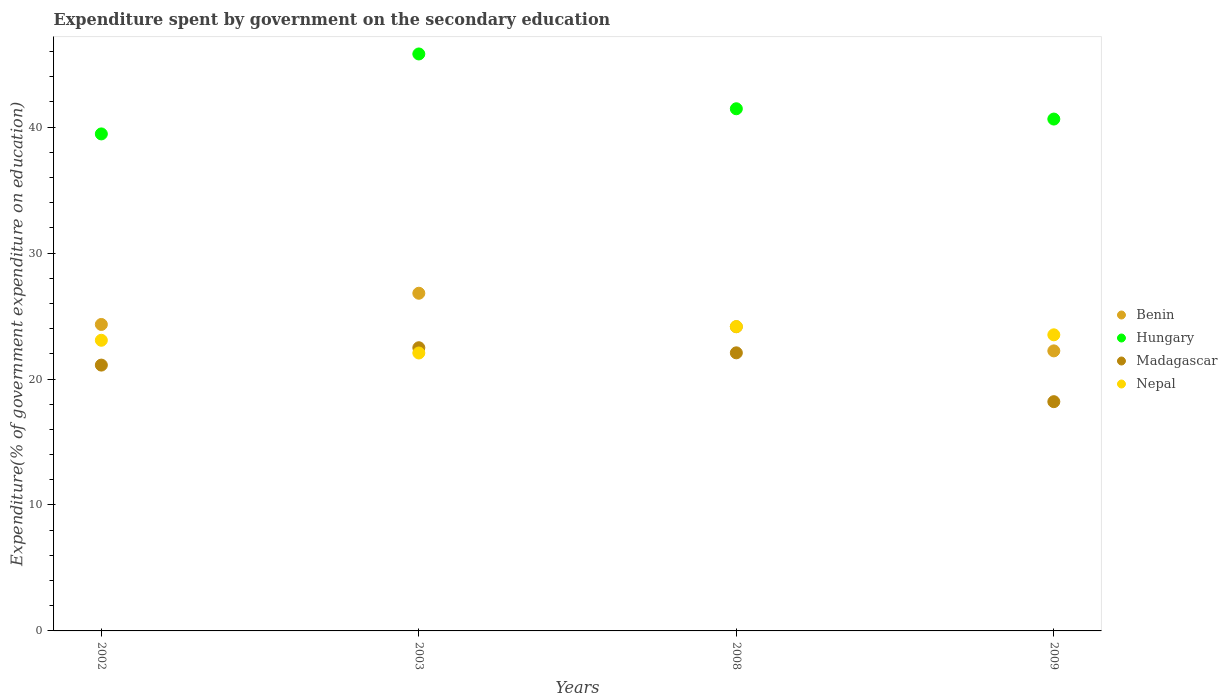How many different coloured dotlines are there?
Give a very brief answer. 4. What is the expenditure spent by government on the secondary education in Benin in 2009?
Provide a succinct answer. 22.23. Across all years, what is the maximum expenditure spent by government on the secondary education in Nepal?
Provide a succinct answer. 24.16. Across all years, what is the minimum expenditure spent by government on the secondary education in Benin?
Give a very brief answer. 22.23. In which year was the expenditure spent by government on the secondary education in Hungary minimum?
Ensure brevity in your answer.  2002. What is the total expenditure spent by government on the secondary education in Benin in the graph?
Offer a very short reply. 97.53. What is the difference between the expenditure spent by government on the secondary education in Hungary in 2002 and that in 2009?
Your answer should be compact. -1.18. What is the difference between the expenditure spent by government on the secondary education in Hungary in 2009 and the expenditure spent by government on the secondary education in Madagascar in 2008?
Your answer should be compact. 18.56. What is the average expenditure spent by government on the secondary education in Hungary per year?
Give a very brief answer. 41.84. In the year 2002, what is the difference between the expenditure spent by government on the secondary education in Nepal and expenditure spent by government on the secondary education in Madagascar?
Your answer should be very brief. 1.97. In how many years, is the expenditure spent by government on the secondary education in Madagascar greater than 4 %?
Offer a very short reply. 4. What is the ratio of the expenditure spent by government on the secondary education in Nepal in 2003 to that in 2009?
Your answer should be very brief. 0.94. What is the difference between the highest and the second highest expenditure spent by government on the secondary education in Benin?
Provide a short and direct response. 2.48. What is the difference between the highest and the lowest expenditure spent by government on the secondary education in Benin?
Keep it short and to the point. 4.58. Is the sum of the expenditure spent by government on the secondary education in Benin in 2002 and 2003 greater than the maximum expenditure spent by government on the secondary education in Madagascar across all years?
Provide a short and direct response. Yes. What is the difference between two consecutive major ticks on the Y-axis?
Ensure brevity in your answer.  10. How many legend labels are there?
Your response must be concise. 4. What is the title of the graph?
Keep it short and to the point. Expenditure spent by government on the secondary education. Does "Barbados" appear as one of the legend labels in the graph?
Your answer should be compact. No. What is the label or title of the X-axis?
Ensure brevity in your answer.  Years. What is the label or title of the Y-axis?
Ensure brevity in your answer.  Expenditure(% of government expenditure on education). What is the Expenditure(% of government expenditure on education) in Benin in 2002?
Make the answer very short. 24.33. What is the Expenditure(% of government expenditure on education) of Hungary in 2002?
Your answer should be very brief. 39.46. What is the Expenditure(% of government expenditure on education) of Madagascar in 2002?
Your answer should be compact. 21.11. What is the Expenditure(% of government expenditure on education) of Nepal in 2002?
Give a very brief answer. 23.08. What is the Expenditure(% of government expenditure on education) of Benin in 2003?
Provide a short and direct response. 26.81. What is the Expenditure(% of government expenditure on education) of Hungary in 2003?
Your answer should be compact. 45.81. What is the Expenditure(% of government expenditure on education) of Madagascar in 2003?
Provide a short and direct response. 22.48. What is the Expenditure(% of government expenditure on education) in Nepal in 2003?
Give a very brief answer. 22.07. What is the Expenditure(% of government expenditure on education) of Benin in 2008?
Ensure brevity in your answer.  24.15. What is the Expenditure(% of government expenditure on education) in Hungary in 2008?
Your response must be concise. 41.46. What is the Expenditure(% of government expenditure on education) in Madagascar in 2008?
Offer a terse response. 22.08. What is the Expenditure(% of government expenditure on education) of Nepal in 2008?
Your response must be concise. 24.16. What is the Expenditure(% of government expenditure on education) of Benin in 2009?
Give a very brief answer. 22.23. What is the Expenditure(% of government expenditure on education) of Hungary in 2009?
Your answer should be very brief. 40.64. What is the Expenditure(% of government expenditure on education) of Madagascar in 2009?
Offer a terse response. 18.2. What is the Expenditure(% of government expenditure on education) of Nepal in 2009?
Your answer should be very brief. 23.51. Across all years, what is the maximum Expenditure(% of government expenditure on education) in Benin?
Offer a terse response. 26.81. Across all years, what is the maximum Expenditure(% of government expenditure on education) of Hungary?
Your answer should be very brief. 45.81. Across all years, what is the maximum Expenditure(% of government expenditure on education) in Madagascar?
Your response must be concise. 22.48. Across all years, what is the maximum Expenditure(% of government expenditure on education) of Nepal?
Your answer should be very brief. 24.16. Across all years, what is the minimum Expenditure(% of government expenditure on education) of Benin?
Your response must be concise. 22.23. Across all years, what is the minimum Expenditure(% of government expenditure on education) in Hungary?
Provide a short and direct response. 39.46. Across all years, what is the minimum Expenditure(% of government expenditure on education) in Madagascar?
Give a very brief answer. 18.2. Across all years, what is the minimum Expenditure(% of government expenditure on education) in Nepal?
Your response must be concise. 22.07. What is the total Expenditure(% of government expenditure on education) in Benin in the graph?
Your answer should be compact. 97.53. What is the total Expenditure(% of government expenditure on education) of Hungary in the graph?
Your answer should be compact. 167.37. What is the total Expenditure(% of government expenditure on education) in Madagascar in the graph?
Provide a short and direct response. 83.87. What is the total Expenditure(% of government expenditure on education) in Nepal in the graph?
Your response must be concise. 92.82. What is the difference between the Expenditure(% of government expenditure on education) of Benin in 2002 and that in 2003?
Provide a succinct answer. -2.48. What is the difference between the Expenditure(% of government expenditure on education) of Hungary in 2002 and that in 2003?
Your answer should be very brief. -6.35. What is the difference between the Expenditure(% of government expenditure on education) of Madagascar in 2002 and that in 2003?
Offer a very short reply. -1.38. What is the difference between the Expenditure(% of government expenditure on education) of Nepal in 2002 and that in 2003?
Your response must be concise. 1.01. What is the difference between the Expenditure(% of government expenditure on education) of Benin in 2002 and that in 2008?
Provide a short and direct response. 0.18. What is the difference between the Expenditure(% of government expenditure on education) in Hungary in 2002 and that in 2008?
Offer a terse response. -2. What is the difference between the Expenditure(% of government expenditure on education) of Madagascar in 2002 and that in 2008?
Your answer should be very brief. -0.97. What is the difference between the Expenditure(% of government expenditure on education) of Nepal in 2002 and that in 2008?
Your response must be concise. -1.09. What is the difference between the Expenditure(% of government expenditure on education) of Benin in 2002 and that in 2009?
Ensure brevity in your answer.  2.1. What is the difference between the Expenditure(% of government expenditure on education) in Hungary in 2002 and that in 2009?
Make the answer very short. -1.18. What is the difference between the Expenditure(% of government expenditure on education) of Madagascar in 2002 and that in 2009?
Keep it short and to the point. 2.9. What is the difference between the Expenditure(% of government expenditure on education) of Nepal in 2002 and that in 2009?
Offer a very short reply. -0.43. What is the difference between the Expenditure(% of government expenditure on education) in Benin in 2003 and that in 2008?
Offer a very short reply. 2.66. What is the difference between the Expenditure(% of government expenditure on education) in Hungary in 2003 and that in 2008?
Your response must be concise. 4.35. What is the difference between the Expenditure(% of government expenditure on education) of Madagascar in 2003 and that in 2008?
Offer a terse response. 0.4. What is the difference between the Expenditure(% of government expenditure on education) of Nepal in 2003 and that in 2008?
Give a very brief answer. -2.1. What is the difference between the Expenditure(% of government expenditure on education) of Benin in 2003 and that in 2009?
Offer a terse response. 4.58. What is the difference between the Expenditure(% of government expenditure on education) in Hungary in 2003 and that in 2009?
Your answer should be compact. 5.17. What is the difference between the Expenditure(% of government expenditure on education) of Madagascar in 2003 and that in 2009?
Your answer should be compact. 4.28. What is the difference between the Expenditure(% of government expenditure on education) of Nepal in 2003 and that in 2009?
Offer a terse response. -1.44. What is the difference between the Expenditure(% of government expenditure on education) of Benin in 2008 and that in 2009?
Keep it short and to the point. 1.92. What is the difference between the Expenditure(% of government expenditure on education) in Hungary in 2008 and that in 2009?
Offer a very short reply. 0.82. What is the difference between the Expenditure(% of government expenditure on education) in Madagascar in 2008 and that in 2009?
Make the answer very short. 3.88. What is the difference between the Expenditure(% of government expenditure on education) in Nepal in 2008 and that in 2009?
Your answer should be very brief. 0.65. What is the difference between the Expenditure(% of government expenditure on education) in Benin in 2002 and the Expenditure(% of government expenditure on education) in Hungary in 2003?
Provide a succinct answer. -21.48. What is the difference between the Expenditure(% of government expenditure on education) of Benin in 2002 and the Expenditure(% of government expenditure on education) of Madagascar in 2003?
Your response must be concise. 1.85. What is the difference between the Expenditure(% of government expenditure on education) in Benin in 2002 and the Expenditure(% of government expenditure on education) in Nepal in 2003?
Offer a terse response. 2.27. What is the difference between the Expenditure(% of government expenditure on education) in Hungary in 2002 and the Expenditure(% of government expenditure on education) in Madagascar in 2003?
Keep it short and to the point. 16.98. What is the difference between the Expenditure(% of government expenditure on education) of Hungary in 2002 and the Expenditure(% of government expenditure on education) of Nepal in 2003?
Your answer should be very brief. 17.39. What is the difference between the Expenditure(% of government expenditure on education) in Madagascar in 2002 and the Expenditure(% of government expenditure on education) in Nepal in 2003?
Provide a short and direct response. -0.96. What is the difference between the Expenditure(% of government expenditure on education) of Benin in 2002 and the Expenditure(% of government expenditure on education) of Hungary in 2008?
Provide a succinct answer. -17.13. What is the difference between the Expenditure(% of government expenditure on education) in Benin in 2002 and the Expenditure(% of government expenditure on education) in Madagascar in 2008?
Provide a succinct answer. 2.25. What is the difference between the Expenditure(% of government expenditure on education) of Benin in 2002 and the Expenditure(% of government expenditure on education) of Nepal in 2008?
Your answer should be compact. 0.17. What is the difference between the Expenditure(% of government expenditure on education) of Hungary in 2002 and the Expenditure(% of government expenditure on education) of Madagascar in 2008?
Your response must be concise. 17.38. What is the difference between the Expenditure(% of government expenditure on education) in Hungary in 2002 and the Expenditure(% of government expenditure on education) in Nepal in 2008?
Offer a very short reply. 15.3. What is the difference between the Expenditure(% of government expenditure on education) in Madagascar in 2002 and the Expenditure(% of government expenditure on education) in Nepal in 2008?
Give a very brief answer. -3.06. What is the difference between the Expenditure(% of government expenditure on education) in Benin in 2002 and the Expenditure(% of government expenditure on education) in Hungary in 2009?
Give a very brief answer. -16.31. What is the difference between the Expenditure(% of government expenditure on education) of Benin in 2002 and the Expenditure(% of government expenditure on education) of Madagascar in 2009?
Your answer should be very brief. 6.13. What is the difference between the Expenditure(% of government expenditure on education) in Benin in 2002 and the Expenditure(% of government expenditure on education) in Nepal in 2009?
Offer a very short reply. 0.82. What is the difference between the Expenditure(% of government expenditure on education) of Hungary in 2002 and the Expenditure(% of government expenditure on education) of Madagascar in 2009?
Keep it short and to the point. 21.26. What is the difference between the Expenditure(% of government expenditure on education) of Hungary in 2002 and the Expenditure(% of government expenditure on education) of Nepal in 2009?
Provide a succinct answer. 15.95. What is the difference between the Expenditure(% of government expenditure on education) of Madagascar in 2002 and the Expenditure(% of government expenditure on education) of Nepal in 2009?
Keep it short and to the point. -2.4. What is the difference between the Expenditure(% of government expenditure on education) in Benin in 2003 and the Expenditure(% of government expenditure on education) in Hungary in 2008?
Offer a very short reply. -14.65. What is the difference between the Expenditure(% of government expenditure on education) of Benin in 2003 and the Expenditure(% of government expenditure on education) of Madagascar in 2008?
Keep it short and to the point. 4.73. What is the difference between the Expenditure(% of government expenditure on education) of Benin in 2003 and the Expenditure(% of government expenditure on education) of Nepal in 2008?
Your answer should be compact. 2.65. What is the difference between the Expenditure(% of government expenditure on education) of Hungary in 2003 and the Expenditure(% of government expenditure on education) of Madagascar in 2008?
Keep it short and to the point. 23.73. What is the difference between the Expenditure(% of government expenditure on education) in Hungary in 2003 and the Expenditure(% of government expenditure on education) in Nepal in 2008?
Offer a terse response. 21.65. What is the difference between the Expenditure(% of government expenditure on education) in Madagascar in 2003 and the Expenditure(% of government expenditure on education) in Nepal in 2008?
Your answer should be compact. -1.68. What is the difference between the Expenditure(% of government expenditure on education) of Benin in 2003 and the Expenditure(% of government expenditure on education) of Hungary in 2009?
Your response must be concise. -13.83. What is the difference between the Expenditure(% of government expenditure on education) in Benin in 2003 and the Expenditure(% of government expenditure on education) in Madagascar in 2009?
Your answer should be very brief. 8.61. What is the difference between the Expenditure(% of government expenditure on education) in Benin in 2003 and the Expenditure(% of government expenditure on education) in Nepal in 2009?
Make the answer very short. 3.3. What is the difference between the Expenditure(% of government expenditure on education) of Hungary in 2003 and the Expenditure(% of government expenditure on education) of Madagascar in 2009?
Your answer should be very brief. 27.61. What is the difference between the Expenditure(% of government expenditure on education) of Hungary in 2003 and the Expenditure(% of government expenditure on education) of Nepal in 2009?
Provide a short and direct response. 22.3. What is the difference between the Expenditure(% of government expenditure on education) of Madagascar in 2003 and the Expenditure(% of government expenditure on education) of Nepal in 2009?
Make the answer very short. -1.03. What is the difference between the Expenditure(% of government expenditure on education) of Benin in 2008 and the Expenditure(% of government expenditure on education) of Hungary in 2009?
Keep it short and to the point. -16.49. What is the difference between the Expenditure(% of government expenditure on education) in Benin in 2008 and the Expenditure(% of government expenditure on education) in Madagascar in 2009?
Keep it short and to the point. 5.95. What is the difference between the Expenditure(% of government expenditure on education) of Benin in 2008 and the Expenditure(% of government expenditure on education) of Nepal in 2009?
Offer a very short reply. 0.64. What is the difference between the Expenditure(% of government expenditure on education) of Hungary in 2008 and the Expenditure(% of government expenditure on education) of Madagascar in 2009?
Your answer should be compact. 23.26. What is the difference between the Expenditure(% of government expenditure on education) in Hungary in 2008 and the Expenditure(% of government expenditure on education) in Nepal in 2009?
Keep it short and to the point. 17.95. What is the difference between the Expenditure(% of government expenditure on education) in Madagascar in 2008 and the Expenditure(% of government expenditure on education) in Nepal in 2009?
Provide a short and direct response. -1.43. What is the average Expenditure(% of government expenditure on education) in Benin per year?
Your answer should be very brief. 24.38. What is the average Expenditure(% of government expenditure on education) of Hungary per year?
Your answer should be very brief. 41.84. What is the average Expenditure(% of government expenditure on education) in Madagascar per year?
Provide a succinct answer. 20.97. What is the average Expenditure(% of government expenditure on education) of Nepal per year?
Keep it short and to the point. 23.2. In the year 2002, what is the difference between the Expenditure(% of government expenditure on education) in Benin and Expenditure(% of government expenditure on education) in Hungary?
Your answer should be compact. -15.13. In the year 2002, what is the difference between the Expenditure(% of government expenditure on education) of Benin and Expenditure(% of government expenditure on education) of Madagascar?
Provide a succinct answer. 3.23. In the year 2002, what is the difference between the Expenditure(% of government expenditure on education) of Benin and Expenditure(% of government expenditure on education) of Nepal?
Ensure brevity in your answer.  1.26. In the year 2002, what is the difference between the Expenditure(% of government expenditure on education) of Hungary and Expenditure(% of government expenditure on education) of Madagascar?
Give a very brief answer. 18.35. In the year 2002, what is the difference between the Expenditure(% of government expenditure on education) of Hungary and Expenditure(% of government expenditure on education) of Nepal?
Keep it short and to the point. 16.38. In the year 2002, what is the difference between the Expenditure(% of government expenditure on education) in Madagascar and Expenditure(% of government expenditure on education) in Nepal?
Your response must be concise. -1.97. In the year 2003, what is the difference between the Expenditure(% of government expenditure on education) in Benin and Expenditure(% of government expenditure on education) in Hungary?
Offer a very short reply. -19. In the year 2003, what is the difference between the Expenditure(% of government expenditure on education) of Benin and Expenditure(% of government expenditure on education) of Madagascar?
Make the answer very short. 4.33. In the year 2003, what is the difference between the Expenditure(% of government expenditure on education) of Benin and Expenditure(% of government expenditure on education) of Nepal?
Your answer should be compact. 4.74. In the year 2003, what is the difference between the Expenditure(% of government expenditure on education) in Hungary and Expenditure(% of government expenditure on education) in Madagascar?
Provide a short and direct response. 23.32. In the year 2003, what is the difference between the Expenditure(% of government expenditure on education) of Hungary and Expenditure(% of government expenditure on education) of Nepal?
Ensure brevity in your answer.  23.74. In the year 2003, what is the difference between the Expenditure(% of government expenditure on education) in Madagascar and Expenditure(% of government expenditure on education) in Nepal?
Keep it short and to the point. 0.42. In the year 2008, what is the difference between the Expenditure(% of government expenditure on education) in Benin and Expenditure(% of government expenditure on education) in Hungary?
Provide a short and direct response. -17.31. In the year 2008, what is the difference between the Expenditure(% of government expenditure on education) in Benin and Expenditure(% of government expenditure on education) in Madagascar?
Ensure brevity in your answer.  2.07. In the year 2008, what is the difference between the Expenditure(% of government expenditure on education) in Benin and Expenditure(% of government expenditure on education) in Nepal?
Keep it short and to the point. -0.01. In the year 2008, what is the difference between the Expenditure(% of government expenditure on education) of Hungary and Expenditure(% of government expenditure on education) of Madagascar?
Provide a succinct answer. 19.38. In the year 2008, what is the difference between the Expenditure(% of government expenditure on education) in Hungary and Expenditure(% of government expenditure on education) in Nepal?
Your response must be concise. 17.29. In the year 2008, what is the difference between the Expenditure(% of government expenditure on education) of Madagascar and Expenditure(% of government expenditure on education) of Nepal?
Provide a succinct answer. -2.08. In the year 2009, what is the difference between the Expenditure(% of government expenditure on education) of Benin and Expenditure(% of government expenditure on education) of Hungary?
Give a very brief answer. -18.41. In the year 2009, what is the difference between the Expenditure(% of government expenditure on education) of Benin and Expenditure(% of government expenditure on education) of Madagascar?
Give a very brief answer. 4.03. In the year 2009, what is the difference between the Expenditure(% of government expenditure on education) of Benin and Expenditure(% of government expenditure on education) of Nepal?
Your response must be concise. -1.27. In the year 2009, what is the difference between the Expenditure(% of government expenditure on education) in Hungary and Expenditure(% of government expenditure on education) in Madagascar?
Keep it short and to the point. 22.44. In the year 2009, what is the difference between the Expenditure(% of government expenditure on education) of Hungary and Expenditure(% of government expenditure on education) of Nepal?
Keep it short and to the point. 17.13. In the year 2009, what is the difference between the Expenditure(% of government expenditure on education) in Madagascar and Expenditure(% of government expenditure on education) in Nepal?
Give a very brief answer. -5.31. What is the ratio of the Expenditure(% of government expenditure on education) in Benin in 2002 to that in 2003?
Provide a succinct answer. 0.91. What is the ratio of the Expenditure(% of government expenditure on education) in Hungary in 2002 to that in 2003?
Give a very brief answer. 0.86. What is the ratio of the Expenditure(% of government expenditure on education) of Madagascar in 2002 to that in 2003?
Offer a terse response. 0.94. What is the ratio of the Expenditure(% of government expenditure on education) of Nepal in 2002 to that in 2003?
Your answer should be very brief. 1.05. What is the ratio of the Expenditure(% of government expenditure on education) of Benin in 2002 to that in 2008?
Give a very brief answer. 1.01. What is the ratio of the Expenditure(% of government expenditure on education) in Hungary in 2002 to that in 2008?
Give a very brief answer. 0.95. What is the ratio of the Expenditure(% of government expenditure on education) in Madagascar in 2002 to that in 2008?
Ensure brevity in your answer.  0.96. What is the ratio of the Expenditure(% of government expenditure on education) in Nepal in 2002 to that in 2008?
Your answer should be very brief. 0.95. What is the ratio of the Expenditure(% of government expenditure on education) of Benin in 2002 to that in 2009?
Offer a terse response. 1.09. What is the ratio of the Expenditure(% of government expenditure on education) in Madagascar in 2002 to that in 2009?
Make the answer very short. 1.16. What is the ratio of the Expenditure(% of government expenditure on education) in Nepal in 2002 to that in 2009?
Your answer should be compact. 0.98. What is the ratio of the Expenditure(% of government expenditure on education) in Benin in 2003 to that in 2008?
Keep it short and to the point. 1.11. What is the ratio of the Expenditure(% of government expenditure on education) of Hungary in 2003 to that in 2008?
Offer a very short reply. 1.1. What is the ratio of the Expenditure(% of government expenditure on education) in Madagascar in 2003 to that in 2008?
Offer a very short reply. 1.02. What is the ratio of the Expenditure(% of government expenditure on education) of Nepal in 2003 to that in 2008?
Your answer should be compact. 0.91. What is the ratio of the Expenditure(% of government expenditure on education) in Benin in 2003 to that in 2009?
Keep it short and to the point. 1.21. What is the ratio of the Expenditure(% of government expenditure on education) of Hungary in 2003 to that in 2009?
Offer a terse response. 1.13. What is the ratio of the Expenditure(% of government expenditure on education) of Madagascar in 2003 to that in 2009?
Your answer should be very brief. 1.24. What is the ratio of the Expenditure(% of government expenditure on education) in Nepal in 2003 to that in 2009?
Give a very brief answer. 0.94. What is the ratio of the Expenditure(% of government expenditure on education) of Benin in 2008 to that in 2009?
Keep it short and to the point. 1.09. What is the ratio of the Expenditure(% of government expenditure on education) of Hungary in 2008 to that in 2009?
Keep it short and to the point. 1.02. What is the ratio of the Expenditure(% of government expenditure on education) in Madagascar in 2008 to that in 2009?
Offer a terse response. 1.21. What is the ratio of the Expenditure(% of government expenditure on education) of Nepal in 2008 to that in 2009?
Offer a very short reply. 1.03. What is the difference between the highest and the second highest Expenditure(% of government expenditure on education) in Benin?
Offer a very short reply. 2.48. What is the difference between the highest and the second highest Expenditure(% of government expenditure on education) in Hungary?
Make the answer very short. 4.35. What is the difference between the highest and the second highest Expenditure(% of government expenditure on education) in Madagascar?
Provide a short and direct response. 0.4. What is the difference between the highest and the second highest Expenditure(% of government expenditure on education) of Nepal?
Make the answer very short. 0.65. What is the difference between the highest and the lowest Expenditure(% of government expenditure on education) of Benin?
Ensure brevity in your answer.  4.58. What is the difference between the highest and the lowest Expenditure(% of government expenditure on education) in Hungary?
Keep it short and to the point. 6.35. What is the difference between the highest and the lowest Expenditure(% of government expenditure on education) of Madagascar?
Your answer should be compact. 4.28. What is the difference between the highest and the lowest Expenditure(% of government expenditure on education) in Nepal?
Provide a short and direct response. 2.1. 